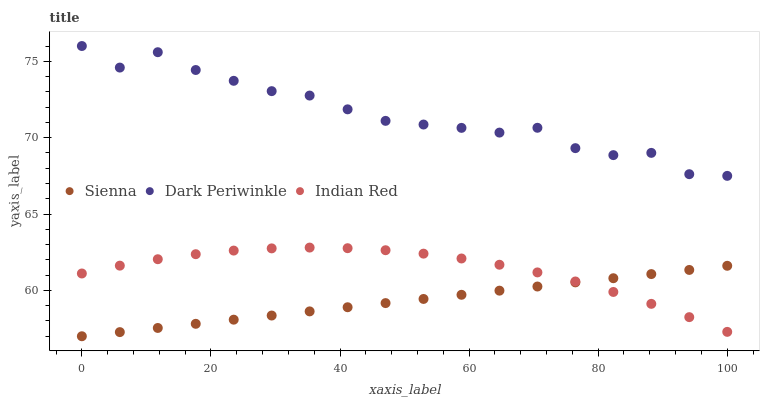Does Sienna have the minimum area under the curve?
Answer yes or no. Yes. Does Dark Periwinkle have the maximum area under the curve?
Answer yes or no. Yes. Does Indian Red have the minimum area under the curve?
Answer yes or no. No. Does Indian Red have the maximum area under the curve?
Answer yes or no. No. Is Sienna the smoothest?
Answer yes or no. Yes. Is Dark Periwinkle the roughest?
Answer yes or no. Yes. Is Indian Red the smoothest?
Answer yes or no. No. Is Indian Red the roughest?
Answer yes or no. No. Does Sienna have the lowest value?
Answer yes or no. Yes. Does Indian Red have the lowest value?
Answer yes or no. No. Does Dark Periwinkle have the highest value?
Answer yes or no. Yes. Does Indian Red have the highest value?
Answer yes or no. No. Is Indian Red less than Dark Periwinkle?
Answer yes or no. Yes. Is Dark Periwinkle greater than Indian Red?
Answer yes or no. Yes. Does Indian Red intersect Sienna?
Answer yes or no. Yes. Is Indian Red less than Sienna?
Answer yes or no. No. Is Indian Red greater than Sienna?
Answer yes or no. No. Does Indian Red intersect Dark Periwinkle?
Answer yes or no. No. 